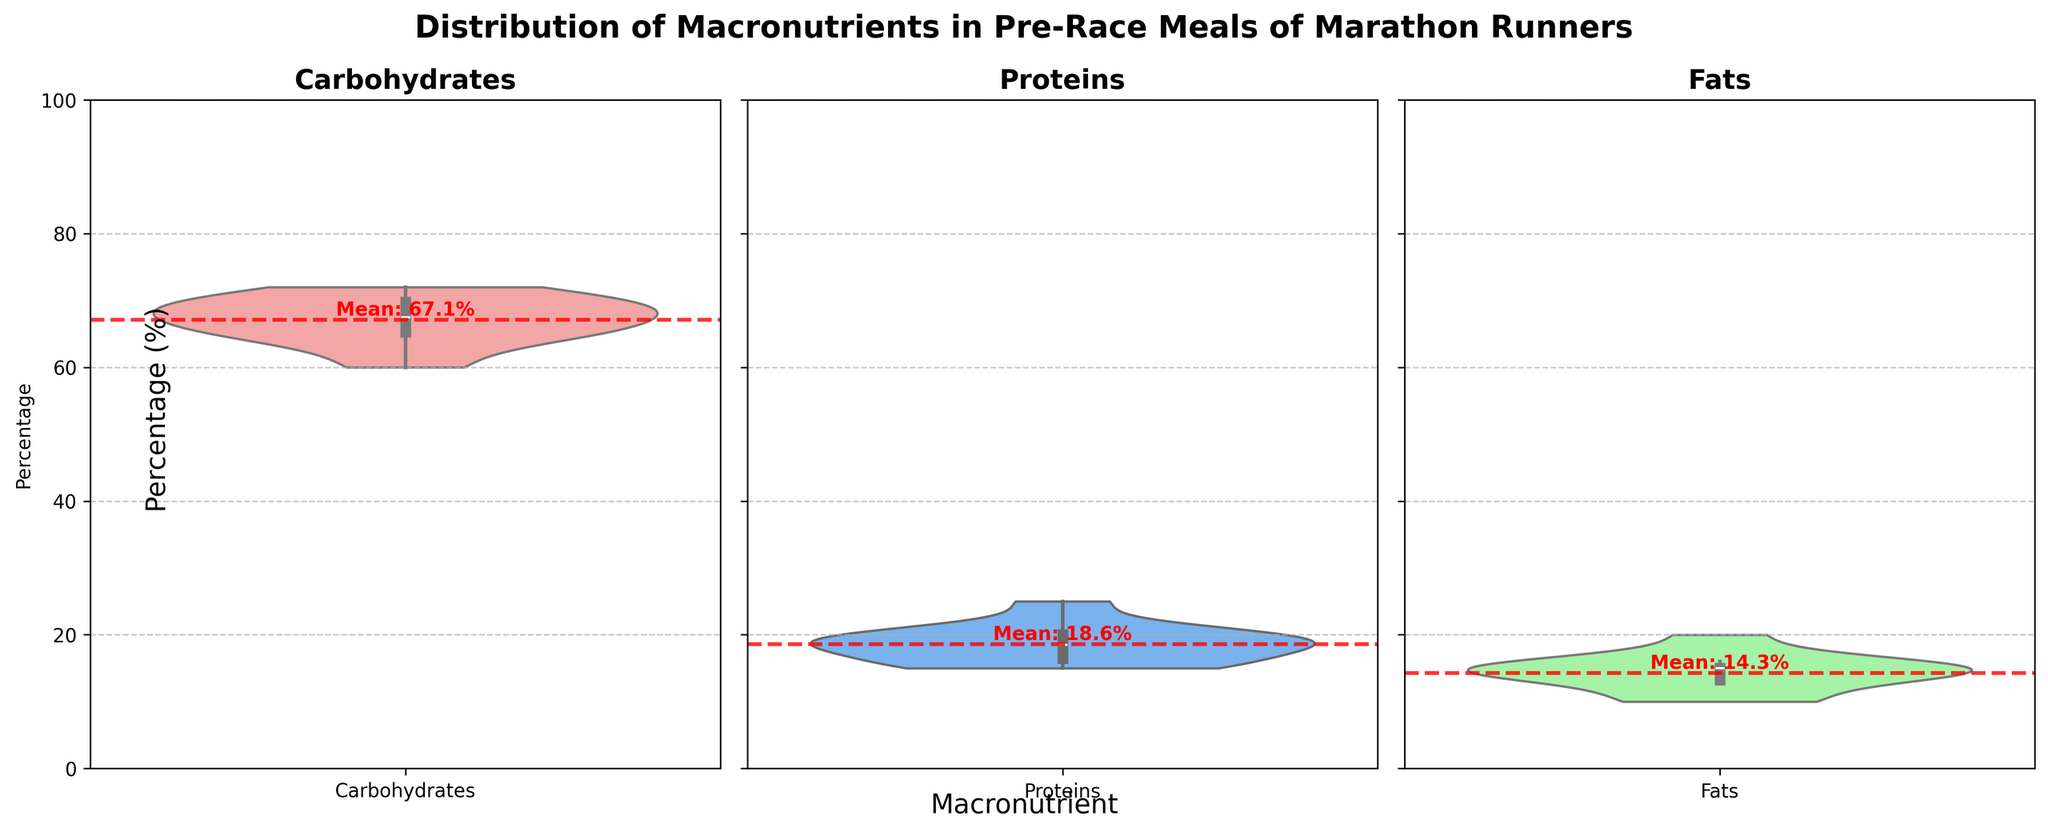How many macronutrient categories are being compared in the figure? The figure shows three violin plots representing different macronutrients, which are labeled as Carbohydrates, Proteins, and Fats.
Answer: 3 What is the average percentage of carbohydrates in pre-race meals? Observe the red mean line in the Carbohydrates violin plot, marked approximately at the mean. The mean is shown as a dashed red line labeled with "Mean".
Answer: 67 Which macronutrient has the widest distribution in percentage? Compare the spread of the violin plots for each macronutrient. The width of the violin represents the distribution of data points.
Answer: Carbohydrates Are carbohydrates generally consumed in higher percentages compared to fats? Compare the range of values in the violin plots for Carbohydrates and Fats. Carbohydrates have a higher median and mean percentage compared to Fats.
Answer: Yes Which macronutrient has the most concentrated percentage values, i.e., smallest spread? Look for the violin plot with the narrowest width. The Proteins violin plot is more concentrated than the others.
Answer: Proteins What is the highest recorded percentage of proteins in pre-race meals? Look at the topmost point of the Proteins violin plot to identify the highest recorded value.
Answer: 25 Is there any overlap in the percentage range of proteins and fats? Compare the violin plots for Proteins and Fats to see if their ranges overlap. Both have values that span similar ranges (around 10-25%).
Answer: Yes Which macronutrient has the most number of times the percentage exceeds 68%? Visually inspect the data density in the respective violin plots above the 68% mark. This is more frequent in the Carbohydrates plot.
Answer: Carbohydrates What is the mean percentage value for fats in pre-race meals? Observe the red mean line in the Fats violin plot, marked approximately at the mean value with "Mean".
Answer: 14.1 